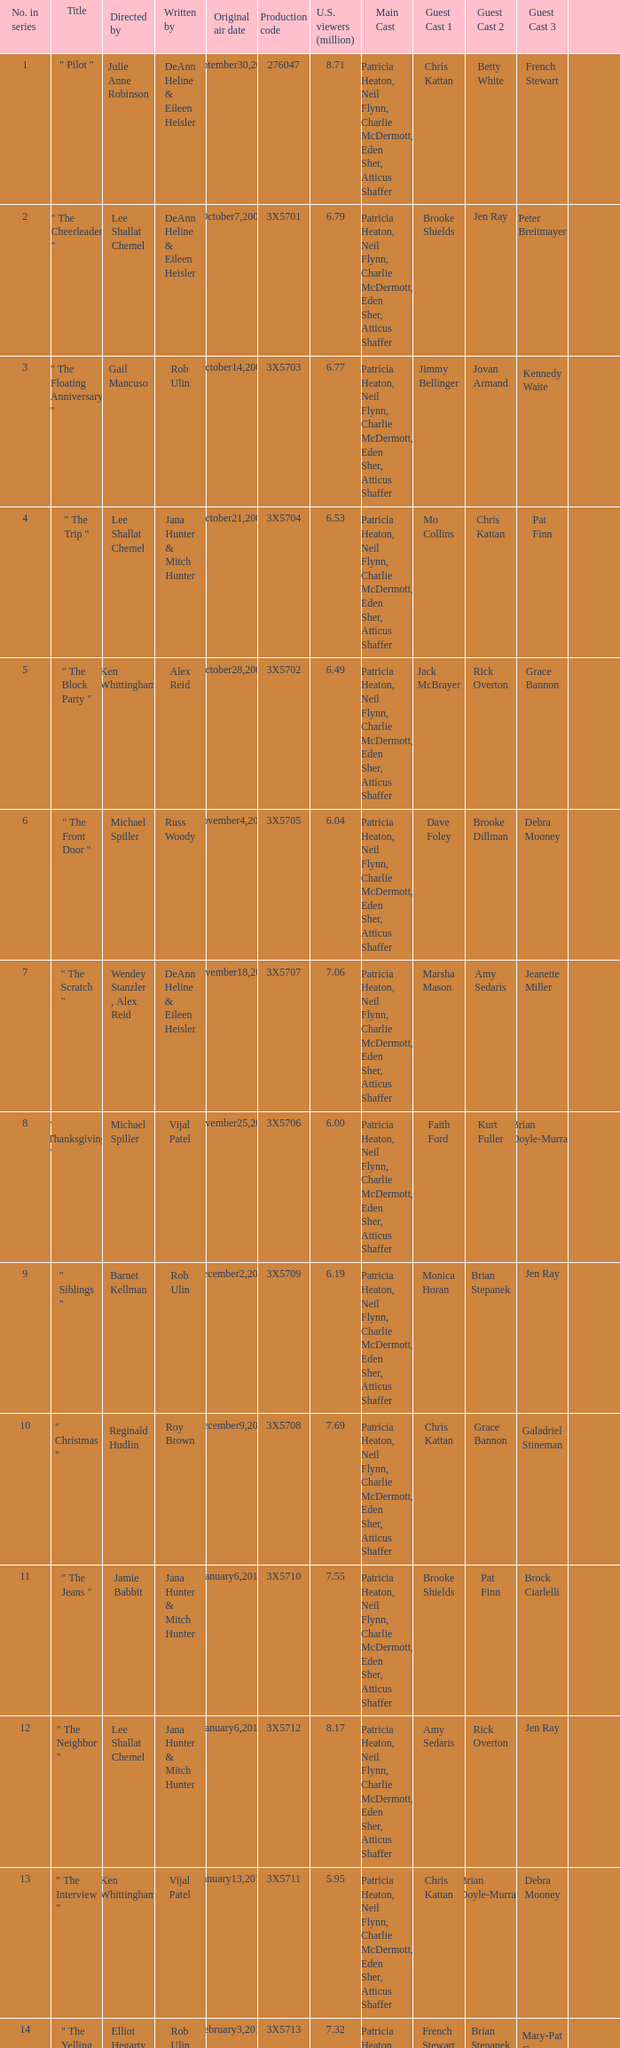Could you parse the entire table as a dict? {'header': ['No. in series', 'Title', 'Directed by', 'Written by', 'Original air date', 'Production code', 'U.S. viewers (million)', 'Main Cast', 'Guest Cast 1', 'Guest Cast 2', 'Guest Cast 3', ''], 'rows': [['1', '" Pilot "', 'Julie Anne Robinson', 'DeAnn Heline & Eileen Heisler', 'September30,2009', '276047', '8.71', 'Patricia Heaton, Neil Flynn, Charlie McDermott, Eden Sher, Atticus Shaffer', 'Chris Kattan', 'Betty White', 'French Stewart', ''], ['2', '" The Cheerleader "', 'Lee Shallat Chemel', 'DeAnn Heline & Eileen Heisler', 'October7,2009', '3X5701', '6.79', 'Patricia Heaton, Neil Flynn, Charlie McDermott, Eden Sher, Atticus Shaffer', 'Brooke Shields', 'Jen Ray', 'Peter Breitmayer', ''], ['3', '" The Floating Anniversary "', 'Gail Mancuso', 'Rob Ulin', 'October14,2009', '3X5703', '6.77', 'Patricia Heaton, Neil Flynn, Charlie McDermott, Eden Sher, Atticus Shaffer', 'Jimmy Bellinger', 'Jovan Armand', 'Kennedy Waite', ''], ['4', '" The Trip "', 'Lee Shallat Chemel', 'Jana Hunter & Mitch Hunter', 'October21,2009', '3X5704', '6.53', 'Patricia Heaton, Neil Flynn, Charlie McDermott, Eden Sher, Atticus Shaffer', 'Mo Collins', 'Chris Kattan', 'Pat Finn', ''], ['5', '" The Block Party "', 'Ken Whittingham', 'Alex Reid', 'October28,2009', '3X5702', '6.49', 'Patricia Heaton, Neil Flynn, Charlie McDermott, Eden Sher, Atticus Shaffer', 'Jack McBrayer', 'Rick Overton', 'Grace Bannon', ''], ['6', '" The Front Door "', 'Michael Spiller', 'Russ Woody', 'November4,2009', '3X5705', '6.04', 'Patricia Heaton, Neil Flynn, Charlie McDermott, Eden Sher, Atticus Shaffer', 'Dave Foley', 'Brooke Dillman', 'Debra Mooney', ''], ['7', '" The Scratch "', 'Wendey Stanzler , Alex Reid', 'DeAnn Heline & Eileen Heisler', 'November18,2009', '3X5707', '7.06', 'Patricia Heaton, Neil Flynn, Charlie McDermott, Eden Sher, Atticus Shaffer', 'Marsha Mason', 'Amy Sedaris', 'Jeanette Miller', ''], ['8', '" Thanksgiving "', 'Michael Spiller', 'Vijal Patel', 'November25,2009', '3X5706', '6.00', 'Patricia Heaton, Neil Flynn, Charlie McDermott, Eden Sher, Atticus Shaffer', 'Faith Ford', 'Kurt Fuller', 'Brian Doyle-Murray', ''], ['9', '" Siblings "', 'Barnet Kellman', 'Rob Ulin', 'December2,2009', '3X5709', '6.19', 'Patricia Heaton, Neil Flynn, Charlie McDermott, Eden Sher, Atticus Shaffer', 'Monica Horan', 'Brian Stepanek', 'Jen Ray', ''], ['10', '" Christmas "', 'Reginald Hudlin', 'Roy Brown', 'December9,2009', '3X5708', '7.69', 'Patricia Heaton, Neil Flynn, Charlie McDermott, Eden Sher, Atticus Shaffer', 'Chris Kattan', 'Grace Bannon', 'Galadriel Stineman', ''], ['11', '" The Jeans "', 'Jamie Babbit', 'Jana Hunter & Mitch Hunter', 'January6,2010', '3X5710', '7.55', 'Patricia Heaton, Neil Flynn, Charlie McDermott, Eden Sher, Atticus Shaffer', 'Brooke Shields', 'Pat Finn', 'Brock Ciarlelli', ''], ['12', '" The Neighbor "', 'Lee Shallat Chemel', 'Jana Hunter & Mitch Hunter', 'January6,2010', '3X5712', '8.17', 'Patricia Heaton, Neil Flynn, Charlie McDermott, Eden Sher, Atticus Shaffer', 'Amy Sedaris', 'Rick Overton', 'Jen Ray', ''], ['13', '" The Interview "', 'Ken Whittingham', 'Vijal Patel', 'January13,2010', '3X5711', '5.95', 'Patricia Heaton, Neil Flynn, Charlie McDermott, Eden Sher, Atticus Shaffer', 'Chris Kattan', 'Brian Doyle-Murray', 'Debra Mooney', ''], ['14', '" The Yelling "', 'Elliot Hegarty', 'Rob Ulin', 'February3,2010', '3X5713', '7.32', 'Patricia Heaton, Neil Flynn, Charlie McDermott, Eden Sher, Atticus Shaffer', 'French Stewart', 'Brian Stepanek', 'Mary-Pat Green', ''], ['15', '" Valentine\'s Day "', 'Chris Koch', 'Bruce Rasmussen', 'February10,2010', '3X5714', '7.83', 'Patricia Heaton, Neil Flynn, Charlie McDermott, Eden Sher, Atticus Shaffer', 'Krista Braun', 'Dave Foley', 'Marsha Mason', ''], ['16', '" The Bee "', 'Ken Whittingham', 'Eileen Heisler & DeAnn Heline', 'March3,2010', '3X5717', '6.02', 'Patricia Heaton, Neil Flynn, Charlie McDermott, Eden Sher, Atticus Shaffer', 'Brian Doyle-Murray', 'Molly Shannon', 'Jack McBrayer', ''], ['17', '"The Break-Up"', 'Wendey Stanzler', 'Vijal Patel', 'March10,2010', '3X5715', '6.32', 'Patricia Heaton, Neil Flynn, Charlie McDermott, Eden Sher, Atticus Shaffer', 'Chris Kattan', 'Jen Ray', "Sean O'Bryan", ''], ['18', '"The Fun House"', 'Chris Koch', 'Roy Brown', 'March24,2010', '3X5716', '7.16', 'Patricia Heaton, Neil Flynn, Charlie McDermott, Eden Sher, Atticus Shaffer', 'Brooke Shields', 'Molly Schreiber', 'Carlos Jacott', ''], ['19', '"The Final Four"', 'Alex Reid', 'Rob Ulin', 'March31,2010', '3X5719', '6.23', 'Patricia Heaton, Neil Flynn, Charlie McDermott, Eden Sher, Atticus Shaffer', 'French Stewart', 'Betty White', 'Jen Ray', ''], ['20', '"TV or Not TV"', 'Lee Shallat Chemel', 'Vijal Patel', 'April14,2010', '3X5718', '6.70', 'Patricia Heaton, Neil Flynn, Charlie McDermott, Eden Sher, Atticus Shaffer', 'Jack McBrayer', 'Jen Ray', 'Sarah Wright Olsen', ''], ['21', '"Worry Duty"', 'Lee Shallat Chemel', 'Bruce Rasmussen', 'April28,2010', '3X5720', '7.10', 'Patricia Heaton, Neil Flynn, Charlie McDermott, Eden Sher, Atticus Shaffer', 'Rachel Dratch', 'Pat Finn', 'Mindy Cohn', ''], ['22', '"Mother\'s Day"', 'Barnet Kellman', 'Mitch Hunter & Jana Hunter', 'May5,2010', '3X5721', '6.75', 'Patricia Heaton, Neil Flynn, Charlie McDermott, Eden Sher, Atticus Shaffer', 'Amy Sedaris', 'Betty White', 'Blaine Saunders', ''], ['23', '"Signals"', 'Jamie Babbit', 'DeAnn Heline & Eileen Heisler', 'May12,2010', '3X5722', '7.49', 'Patricia Heaton, Neil Flynn, Charlie McDermott, Eden Sher, Atticus Shaffer', 'Dave Foley', 'Marsha Mason', 'Jen Ray', '']]} How many directors got 6.79 million U.S. viewers from their episodes? 1.0. 